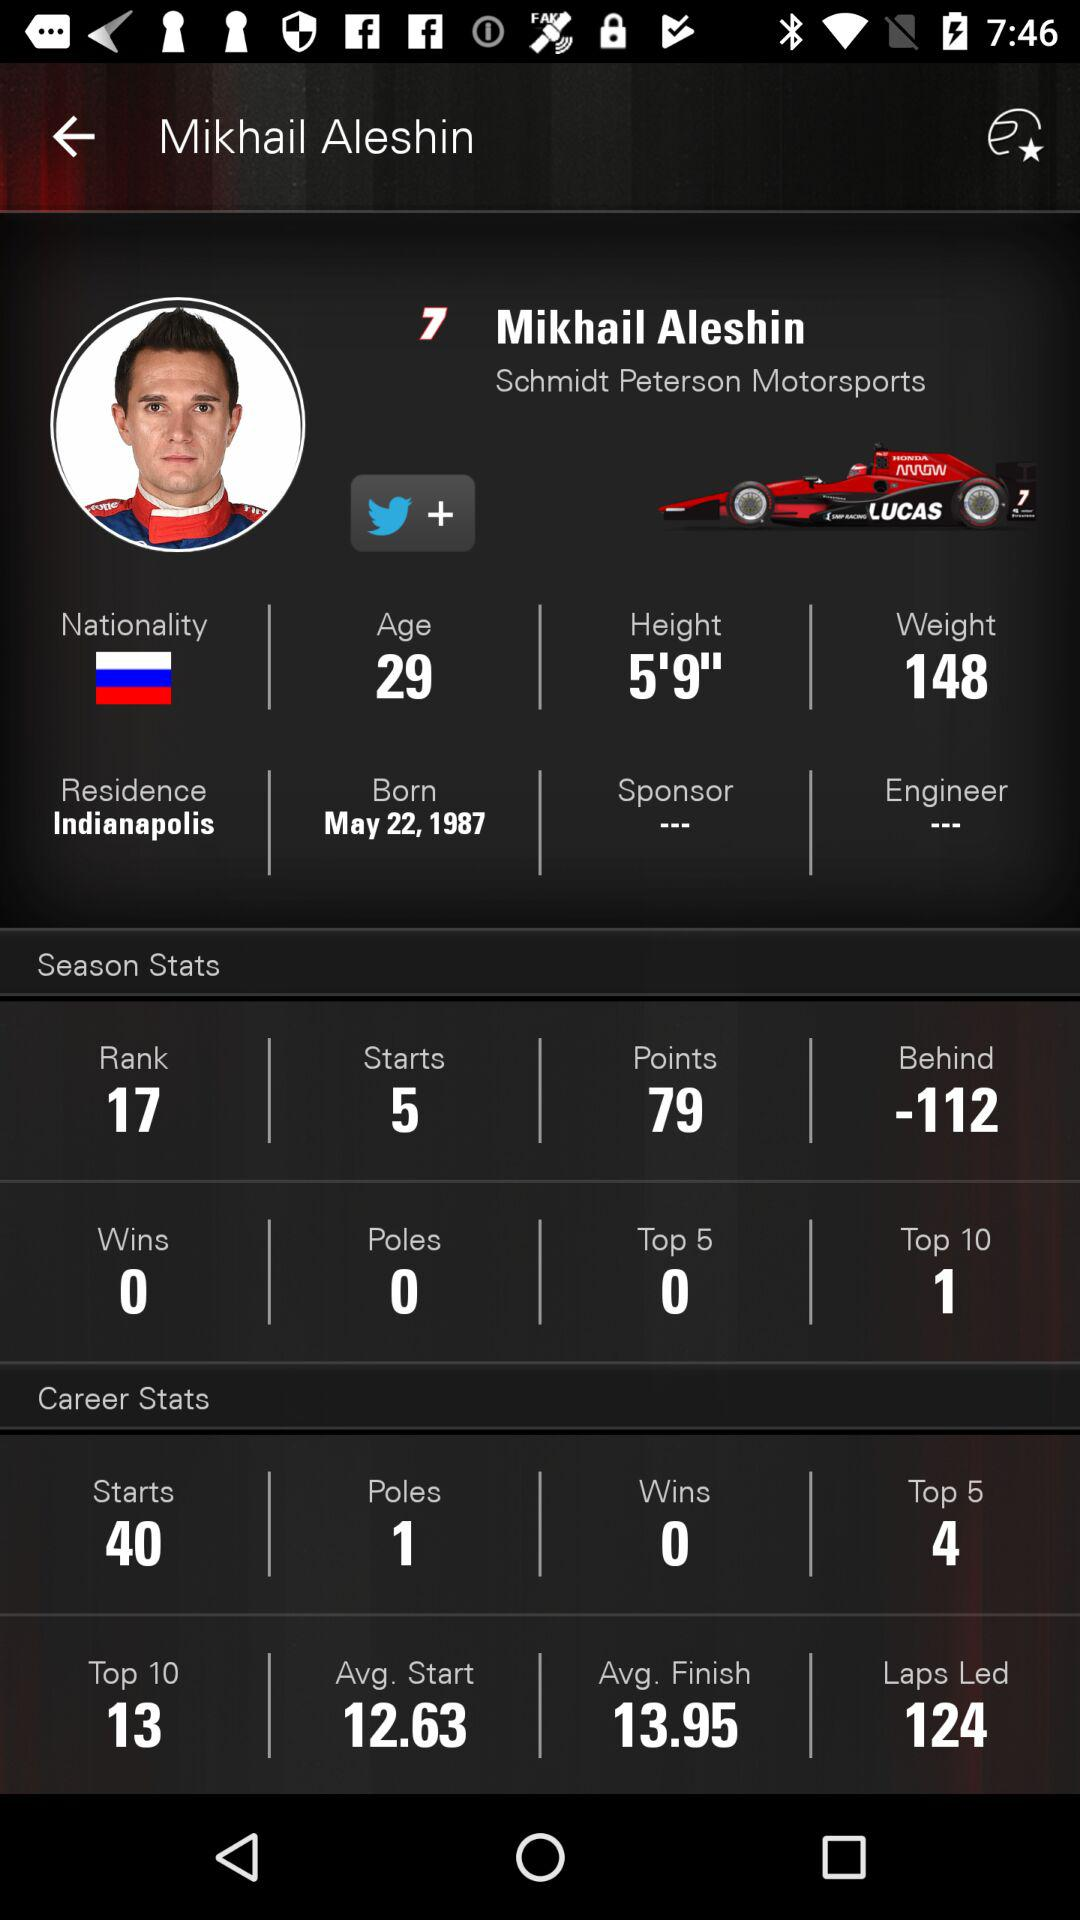How tall is the person? The person is 5 feet 9 inches tall. 